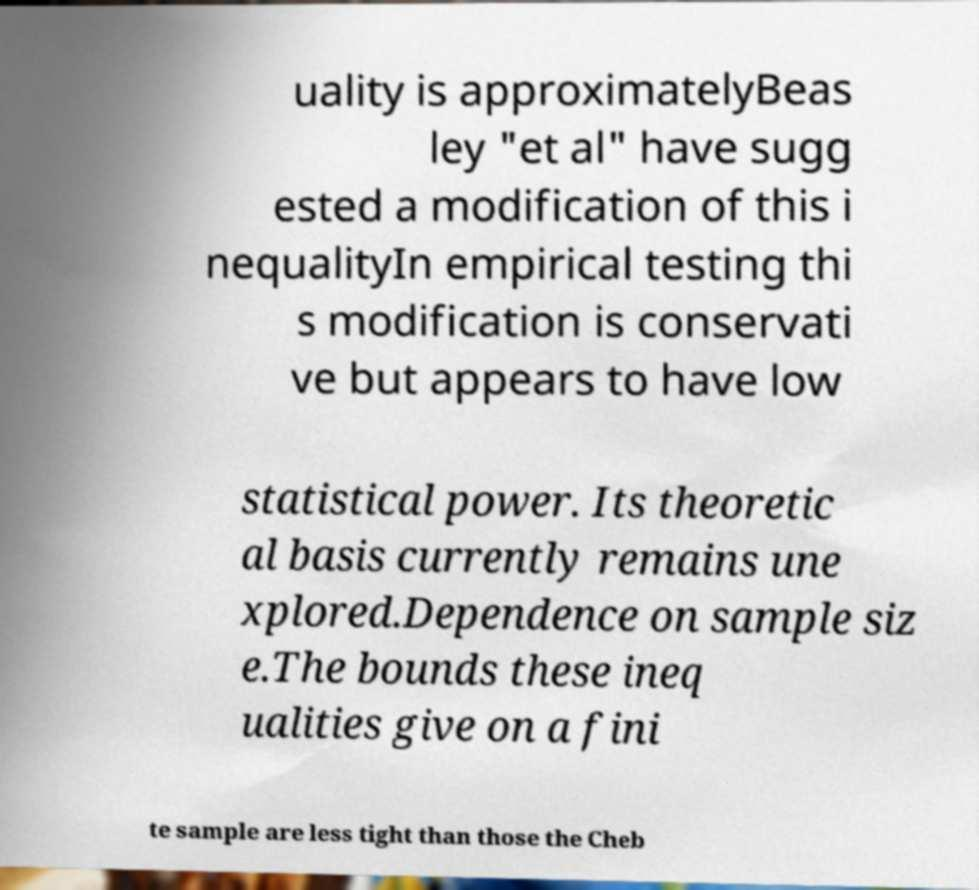Can you read and provide the text displayed in the image?This photo seems to have some interesting text. Can you extract and type it out for me? uality is approximatelyBeas ley "et al" have sugg ested a modification of this i nequalityIn empirical testing thi s modification is conservati ve but appears to have low statistical power. Its theoretic al basis currently remains une xplored.Dependence on sample siz e.The bounds these ineq ualities give on a fini te sample are less tight than those the Cheb 